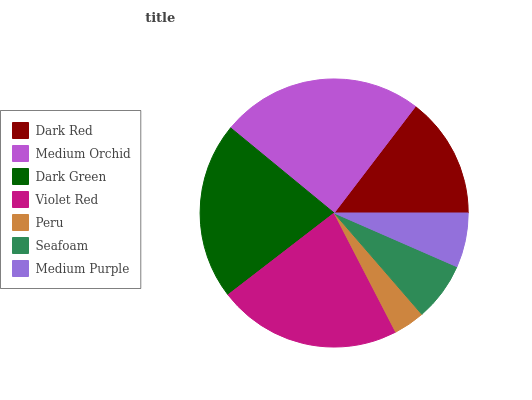Is Peru the minimum?
Answer yes or no. Yes. Is Medium Orchid the maximum?
Answer yes or no. Yes. Is Dark Green the minimum?
Answer yes or no. No. Is Dark Green the maximum?
Answer yes or no. No. Is Medium Orchid greater than Dark Green?
Answer yes or no. Yes. Is Dark Green less than Medium Orchid?
Answer yes or no. Yes. Is Dark Green greater than Medium Orchid?
Answer yes or no. No. Is Medium Orchid less than Dark Green?
Answer yes or no. No. Is Dark Red the high median?
Answer yes or no. Yes. Is Dark Red the low median?
Answer yes or no. Yes. Is Medium Purple the high median?
Answer yes or no. No. Is Seafoam the low median?
Answer yes or no. No. 